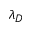<formula> <loc_0><loc_0><loc_500><loc_500>\lambda _ { D }</formula> 